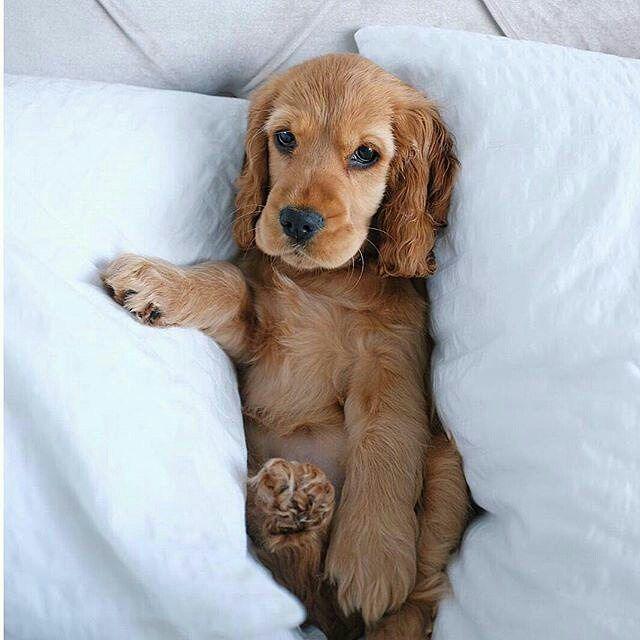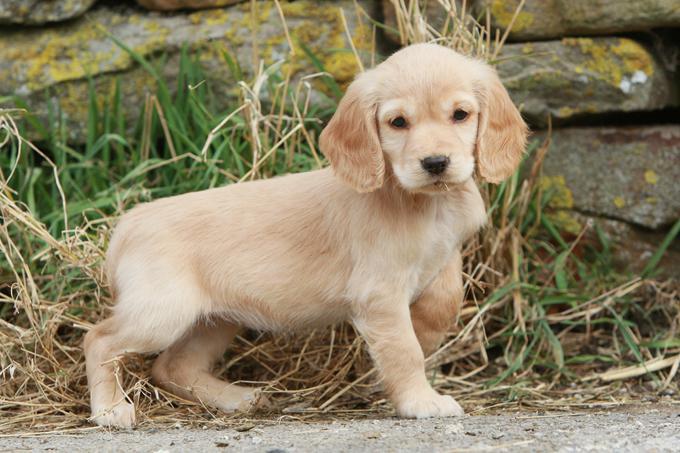The first image is the image on the left, the second image is the image on the right. Given the left and right images, does the statement "Together, the two images show a puppy and a full-grown spaniel." hold true? Answer yes or no. No. 